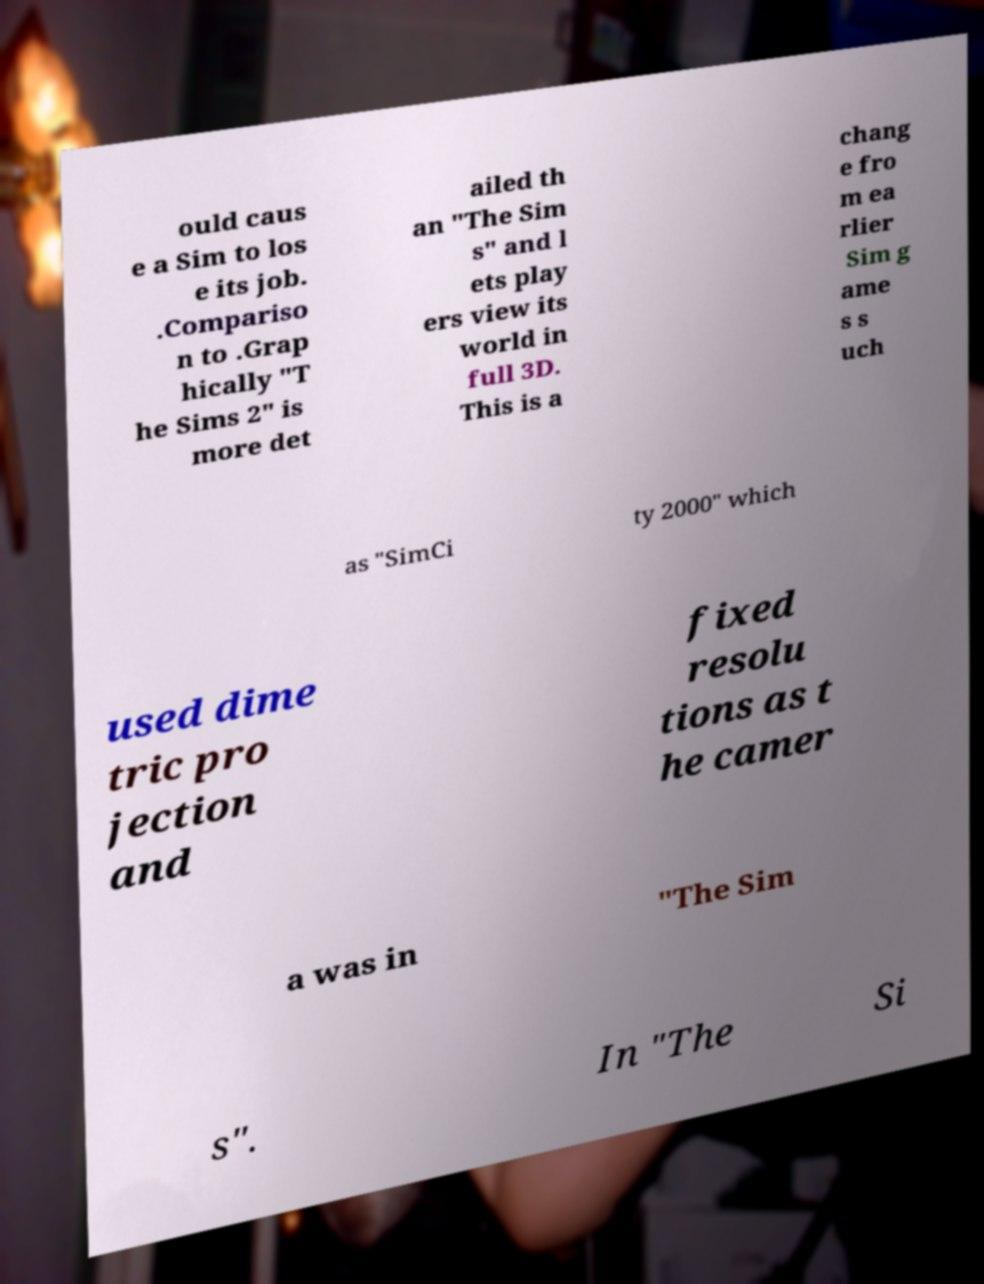Can you accurately transcribe the text from the provided image for me? ould caus e a Sim to los e its job. .Compariso n to .Grap hically "T he Sims 2" is more det ailed th an "The Sim s" and l ets play ers view its world in full 3D. This is a chang e fro m ea rlier Sim g ame s s uch as "SimCi ty 2000" which used dime tric pro jection and fixed resolu tions as t he camer a was in "The Sim s". In "The Si 